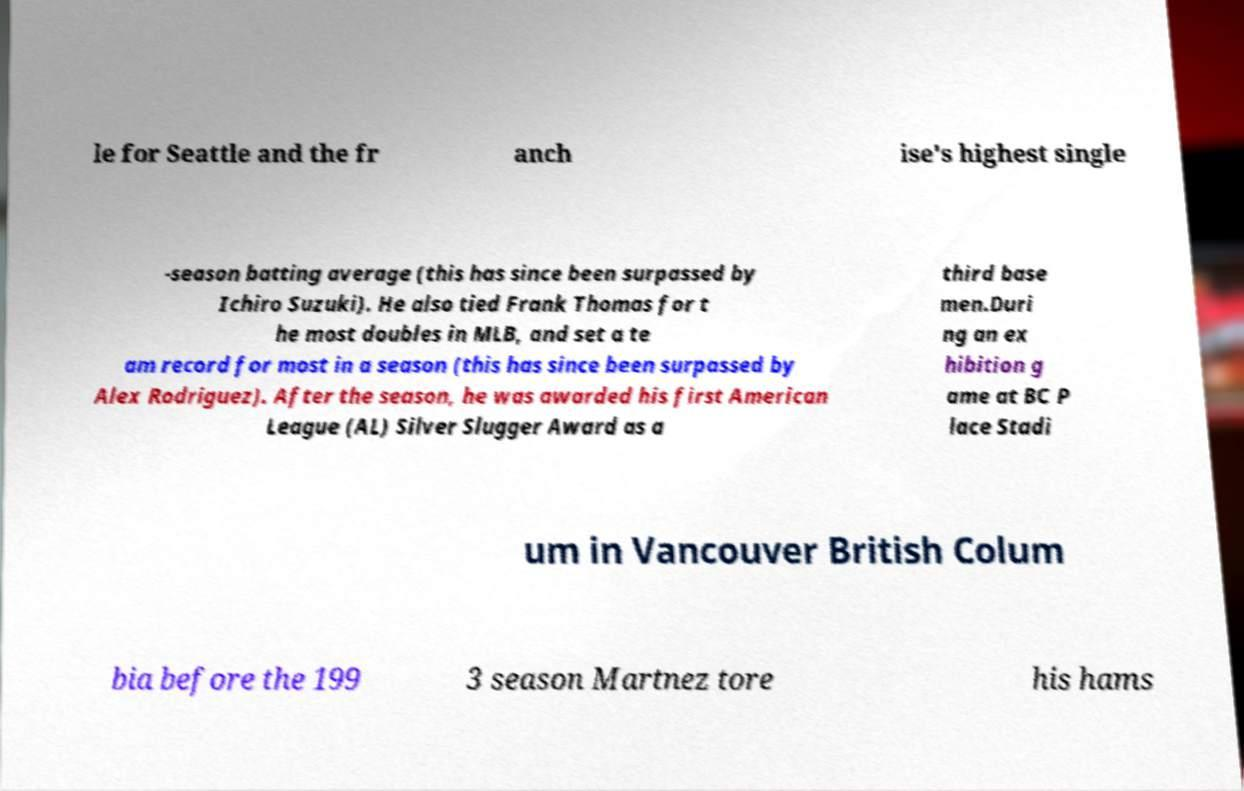Can you accurately transcribe the text from the provided image for me? le for Seattle and the fr anch ise's highest single -season batting average (this has since been surpassed by Ichiro Suzuki). He also tied Frank Thomas for t he most doubles in MLB, and set a te am record for most in a season (this has since been surpassed by Alex Rodriguez). After the season, he was awarded his first American League (AL) Silver Slugger Award as a third base men.Duri ng an ex hibition g ame at BC P lace Stadi um in Vancouver British Colum bia before the 199 3 season Martnez tore his hams 